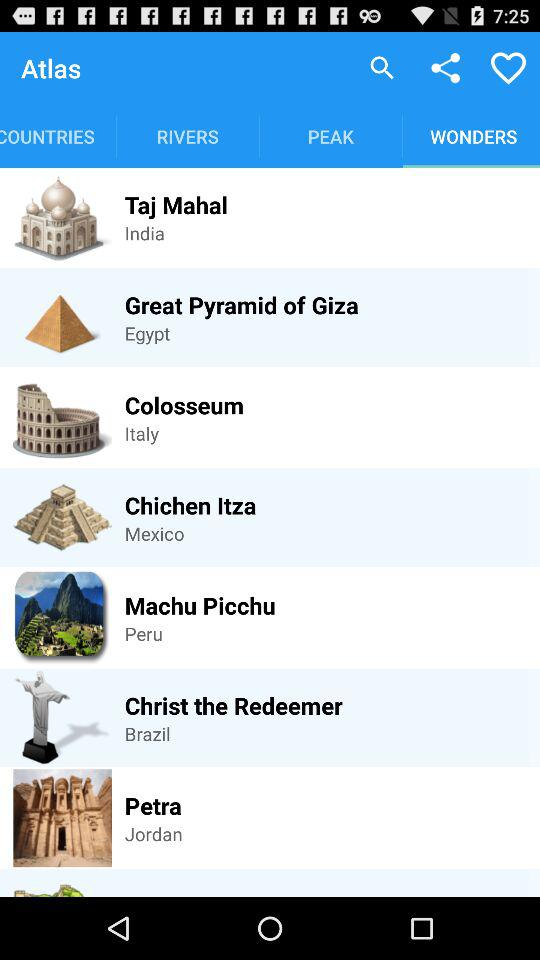What is the wonder of Mexico? The wonder of Mexico is Chichen Itza. 